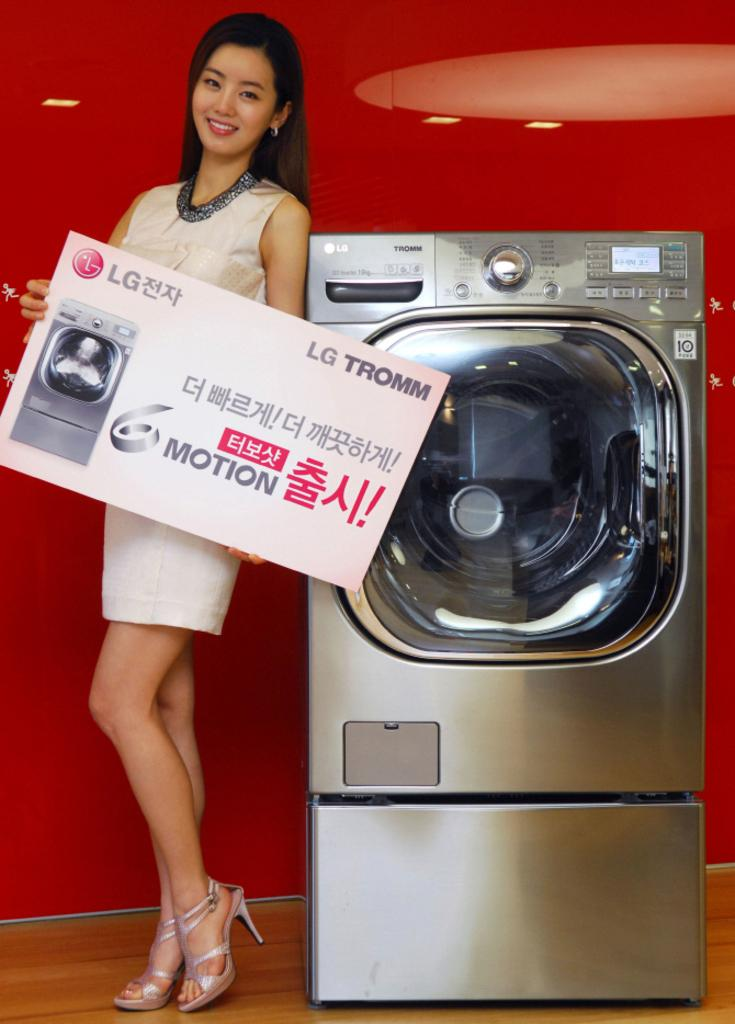<image>
Describe the image concisely. a model is holding an LG sign beside a washing machine 